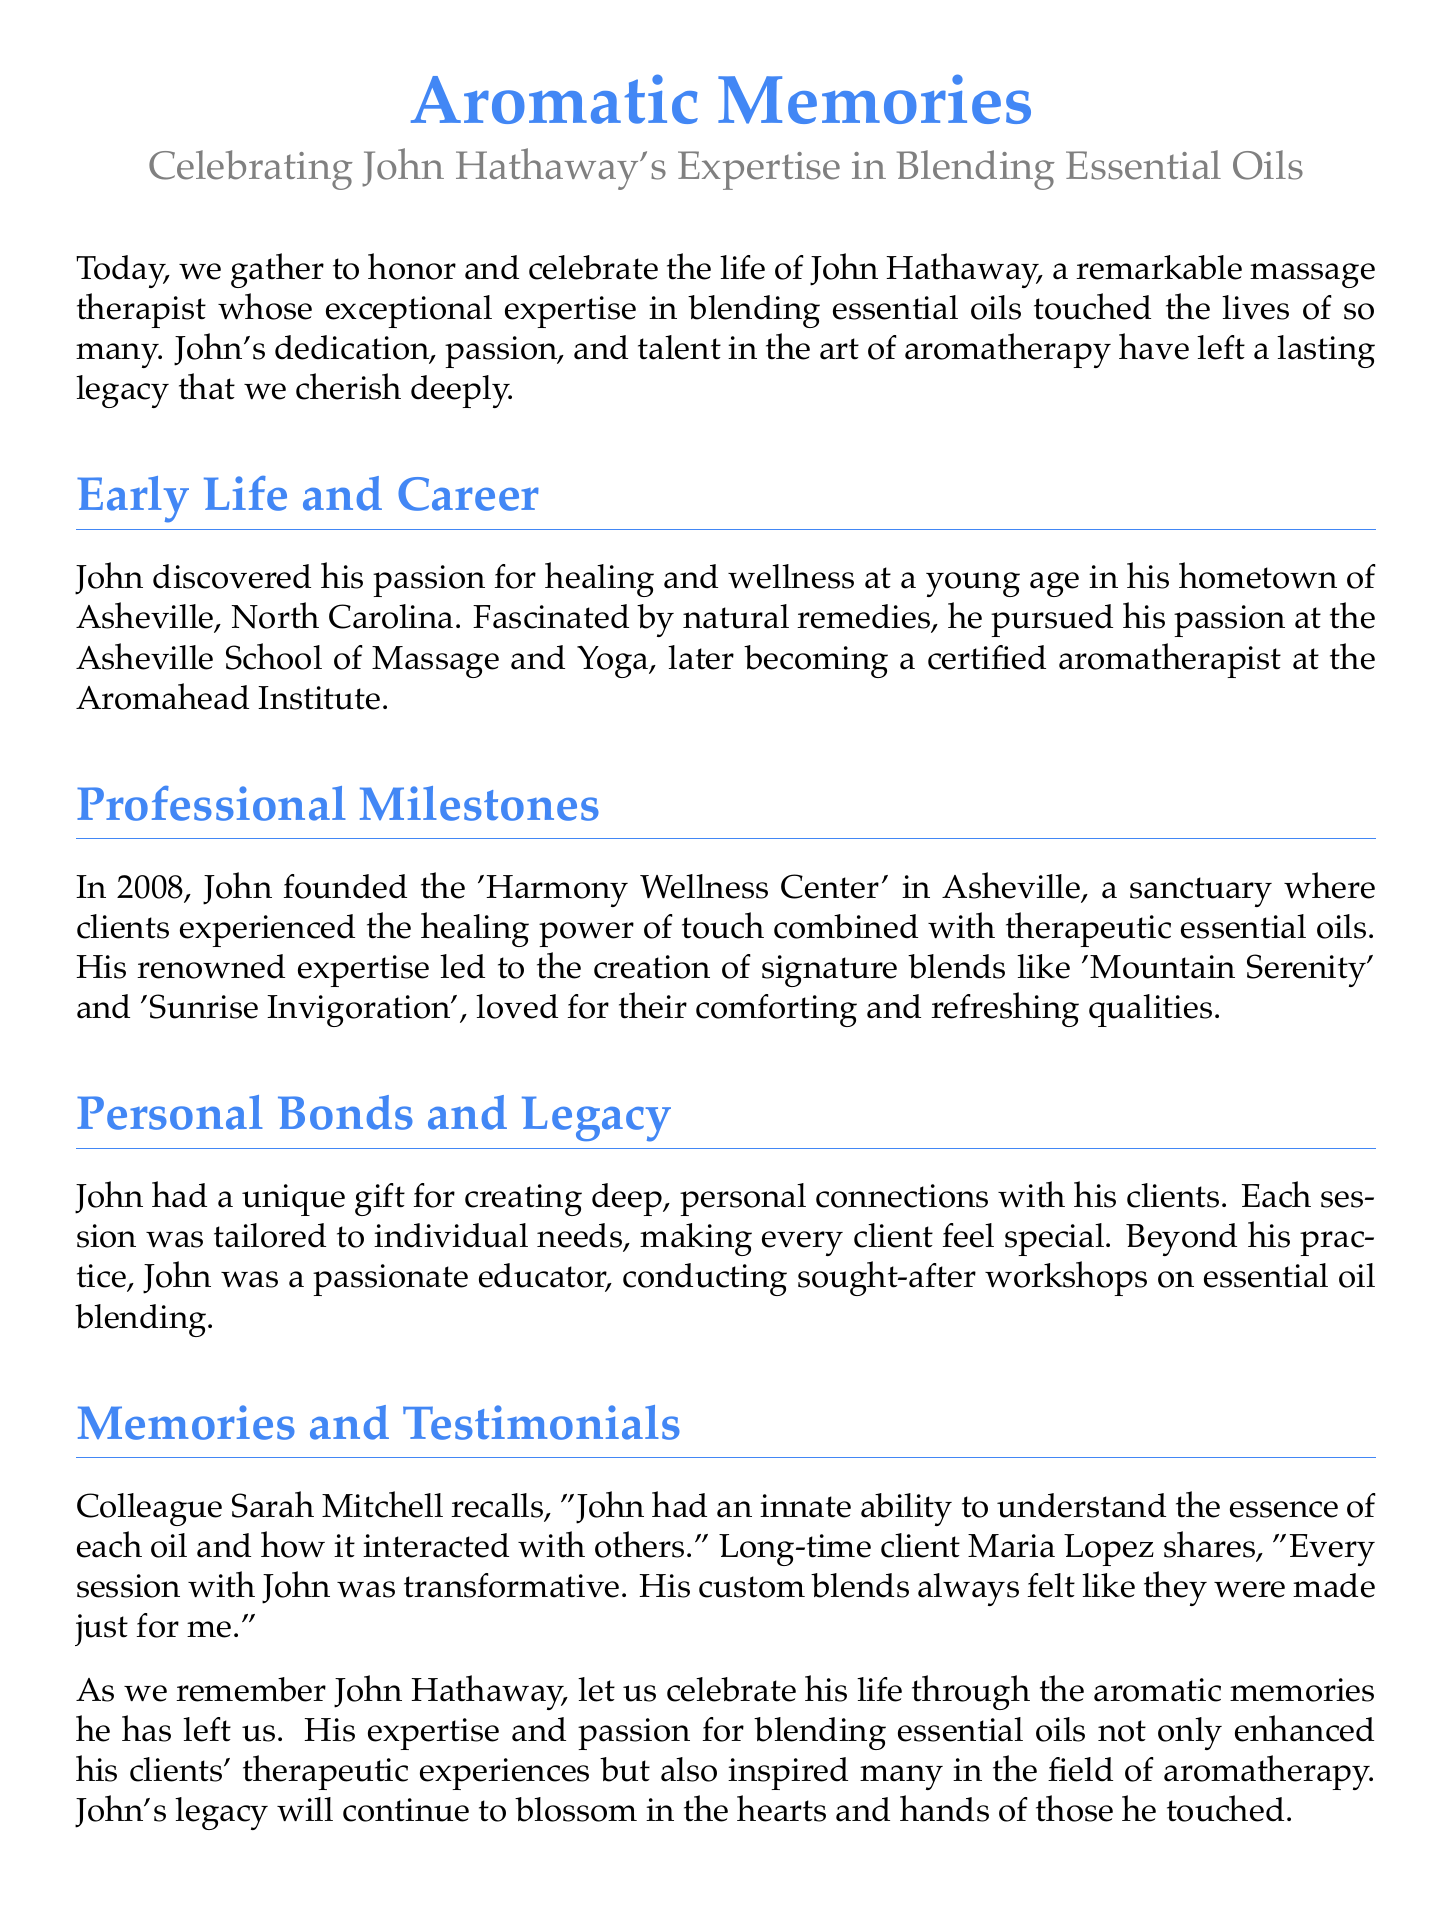What was John's profession? The document describes John's profession as a massage therapist, emphasizing his expertise in blending essential oils.
Answer: massage therapist In which year did John found the 'Harmony Wellness Center'? The document states that John founded the 'Harmony Wellness Center' in 2008, marking a significant milestone in his career.
Answer: 2008 What city was John Hathaway from? The document mentions that John was from Asheville, North Carolina, highlighting his early life and career beginnings.
Answer: Asheville What was the name of John's notable blend associated with comfort? The document references 'Mountain Serenity' as one of the signature blends known for its comforting qualities.
Answer: Mountain Serenity Who is the colleague that recalled John's abilities? According to the document, colleague Sarah Mitchell recalls John's unique abilities in understanding essential oils.
Answer: Sarah Mitchell What type of workshops did John conduct? The document notes that John conducted workshops on essential oil blending, sharing his knowledge with others.
Answer: essential oil blending Which quality is commonly associated with John's custom blends according to Maria Lopez? The document specifies that Maria Lopez felt John's blends were transformative and tailored specifically for her needs.
Answer: transformative What phrase describes John's lasting legacy? The document describes John's legacy as something that will continue to blossom in the hearts and hands of those he touched.
Answer: blossom in the hearts and hands What key characteristic did John have with his clients? The document highlights that John had the unique gift of creating deep, personal connections with his clients during sessions.
Answer: personal connections 